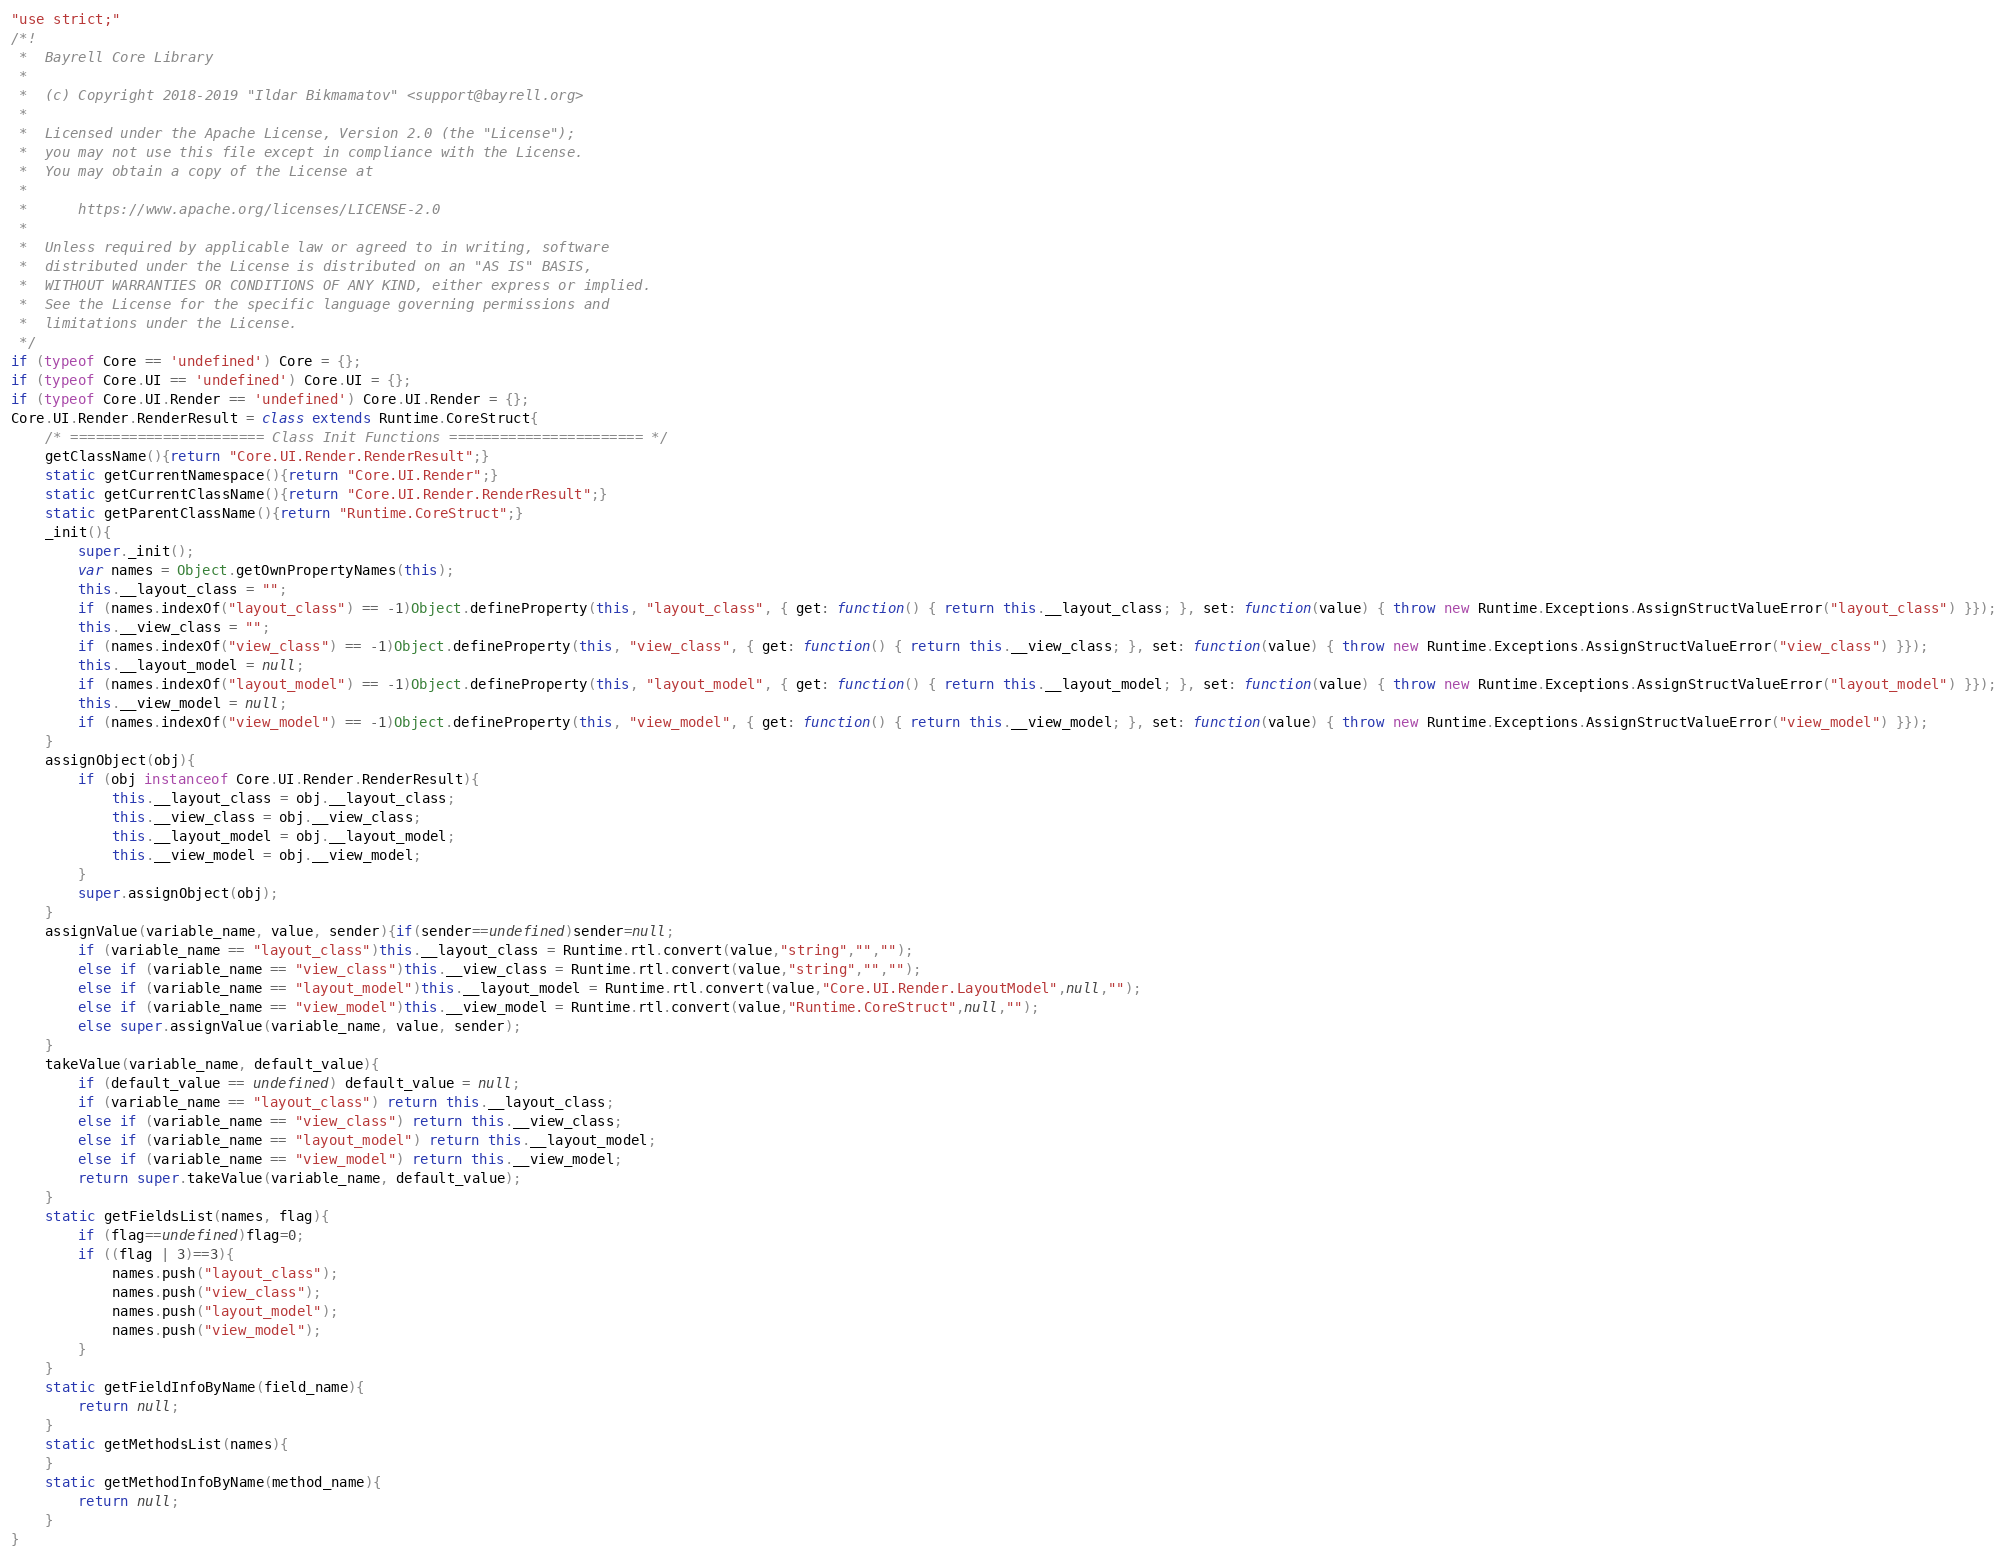<code> <loc_0><loc_0><loc_500><loc_500><_JavaScript_>"use strict;"
/*!
 *  Bayrell Core Library
 *
 *  (c) Copyright 2018-2019 "Ildar Bikmamatov" <support@bayrell.org>
 *
 *  Licensed under the Apache License, Version 2.0 (the "License");
 *  you may not use this file except in compliance with the License.
 *  You may obtain a copy of the License at
 *
 *      https://www.apache.org/licenses/LICENSE-2.0
 *
 *  Unless required by applicable law or agreed to in writing, software
 *  distributed under the License is distributed on an "AS IS" BASIS,
 *  WITHOUT WARRANTIES OR CONDITIONS OF ANY KIND, either express or implied.
 *  See the License for the specific language governing permissions and
 *  limitations under the License.
 */
if (typeof Core == 'undefined') Core = {};
if (typeof Core.UI == 'undefined') Core.UI = {};
if (typeof Core.UI.Render == 'undefined') Core.UI.Render = {};
Core.UI.Render.RenderResult = class extends Runtime.CoreStruct{
	/* ======================= Class Init Functions ======================= */
	getClassName(){return "Core.UI.Render.RenderResult";}
	static getCurrentNamespace(){return "Core.UI.Render";}
	static getCurrentClassName(){return "Core.UI.Render.RenderResult";}
	static getParentClassName(){return "Runtime.CoreStruct";}
	_init(){
		super._init();
		var names = Object.getOwnPropertyNames(this);
		this.__layout_class = "";
		if (names.indexOf("layout_class") == -1)Object.defineProperty(this, "layout_class", { get: function() { return this.__layout_class; }, set: function(value) { throw new Runtime.Exceptions.AssignStructValueError("layout_class") }});
		this.__view_class = "";
		if (names.indexOf("view_class") == -1)Object.defineProperty(this, "view_class", { get: function() { return this.__view_class; }, set: function(value) { throw new Runtime.Exceptions.AssignStructValueError("view_class") }});
		this.__layout_model = null;
		if (names.indexOf("layout_model") == -1)Object.defineProperty(this, "layout_model", { get: function() { return this.__layout_model; }, set: function(value) { throw new Runtime.Exceptions.AssignStructValueError("layout_model") }});
		this.__view_model = null;
		if (names.indexOf("view_model") == -1)Object.defineProperty(this, "view_model", { get: function() { return this.__view_model; }, set: function(value) { throw new Runtime.Exceptions.AssignStructValueError("view_model") }});
	}
	assignObject(obj){
		if (obj instanceof Core.UI.Render.RenderResult){
			this.__layout_class = obj.__layout_class;
			this.__view_class = obj.__view_class;
			this.__layout_model = obj.__layout_model;
			this.__view_model = obj.__view_model;
		}
		super.assignObject(obj);
	}
	assignValue(variable_name, value, sender){if(sender==undefined)sender=null;
		if (variable_name == "layout_class")this.__layout_class = Runtime.rtl.convert(value,"string","","");
		else if (variable_name == "view_class")this.__view_class = Runtime.rtl.convert(value,"string","","");
		else if (variable_name == "layout_model")this.__layout_model = Runtime.rtl.convert(value,"Core.UI.Render.LayoutModel",null,"");
		else if (variable_name == "view_model")this.__view_model = Runtime.rtl.convert(value,"Runtime.CoreStruct",null,"");
		else super.assignValue(variable_name, value, sender);
	}
	takeValue(variable_name, default_value){
		if (default_value == undefined) default_value = null;
		if (variable_name == "layout_class") return this.__layout_class;
		else if (variable_name == "view_class") return this.__view_class;
		else if (variable_name == "layout_model") return this.__layout_model;
		else if (variable_name == "view_model") return this.__view_model;
		return super.takeValue(variable_name, default_value);
	}
	static getFieldsList(names, flag){
		if (flag==undefined)flag=0;
		if ((flag | 3)==3){
			names.push("layout_class");
			names.push("view_class");
			names.push("layout_model");
			names.push("view_model");
		}
	}
	static getFieldInfoByName(field_name){
		return null;
	}
	static getMethodsList(names){
	}
	static getMethodInfoByName(method_name){
		return null;
	}
}</code> 